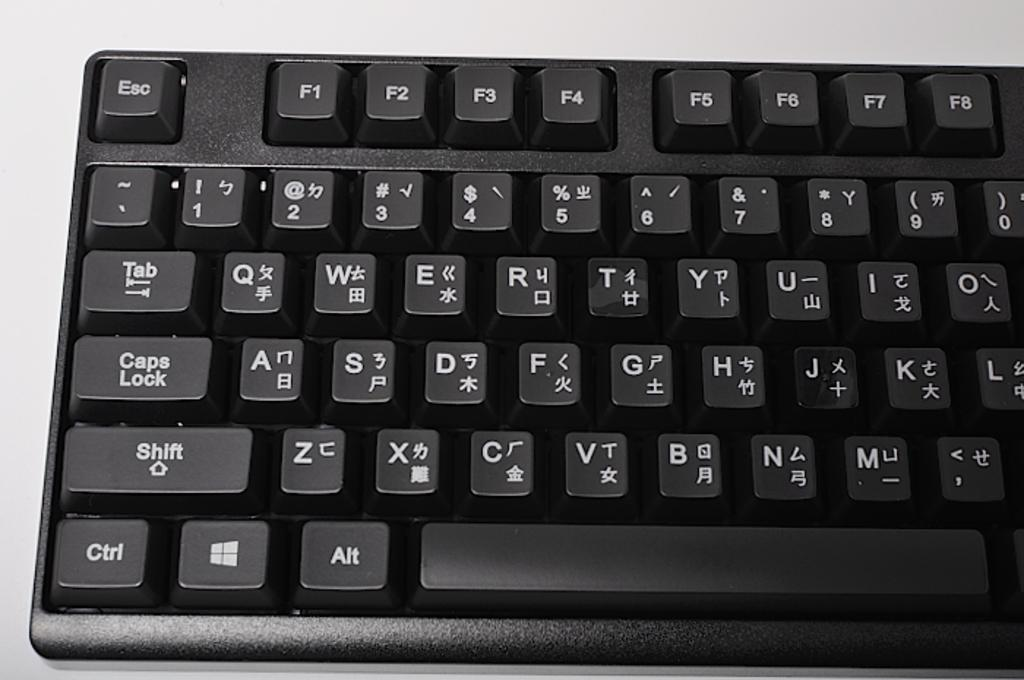Provide a one-sentence caption for the provided image. a keyboard with both english and chinese input labels. 